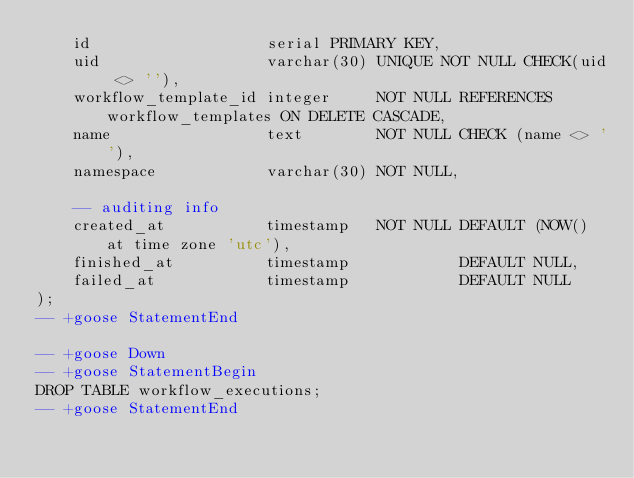Convert code to text. <code><loc_0><loc_0><loc_500><loc_500><_SQL_>    id                   serial PRIMARY KEY,
    uid                  varchar(30) UNIQUE NOT NULL CHECK(uid <> ''),
    workflow_template_id integer     NOT NULL REFERENCES workflow_templates ON DELETE CASCADE,
    name                 text        NOT NULL CHECK (name <> ''),
    namespace            varchar(30) NOT NULL,

    -- auditing info
    created_at           timestamp   NOT NULL DEFAULT (NOW() at time zone 'utc'),
    finished_at          timestamp            DEFAULT NULL,
    failed_at            timestamp            DEFAULT NULL
);
-- +goose StatementEnd

-- +goose Down
-- +goose StatementBegin
DROP TABLE workflow_executions;
-- +goose StatementEnd
</code> 